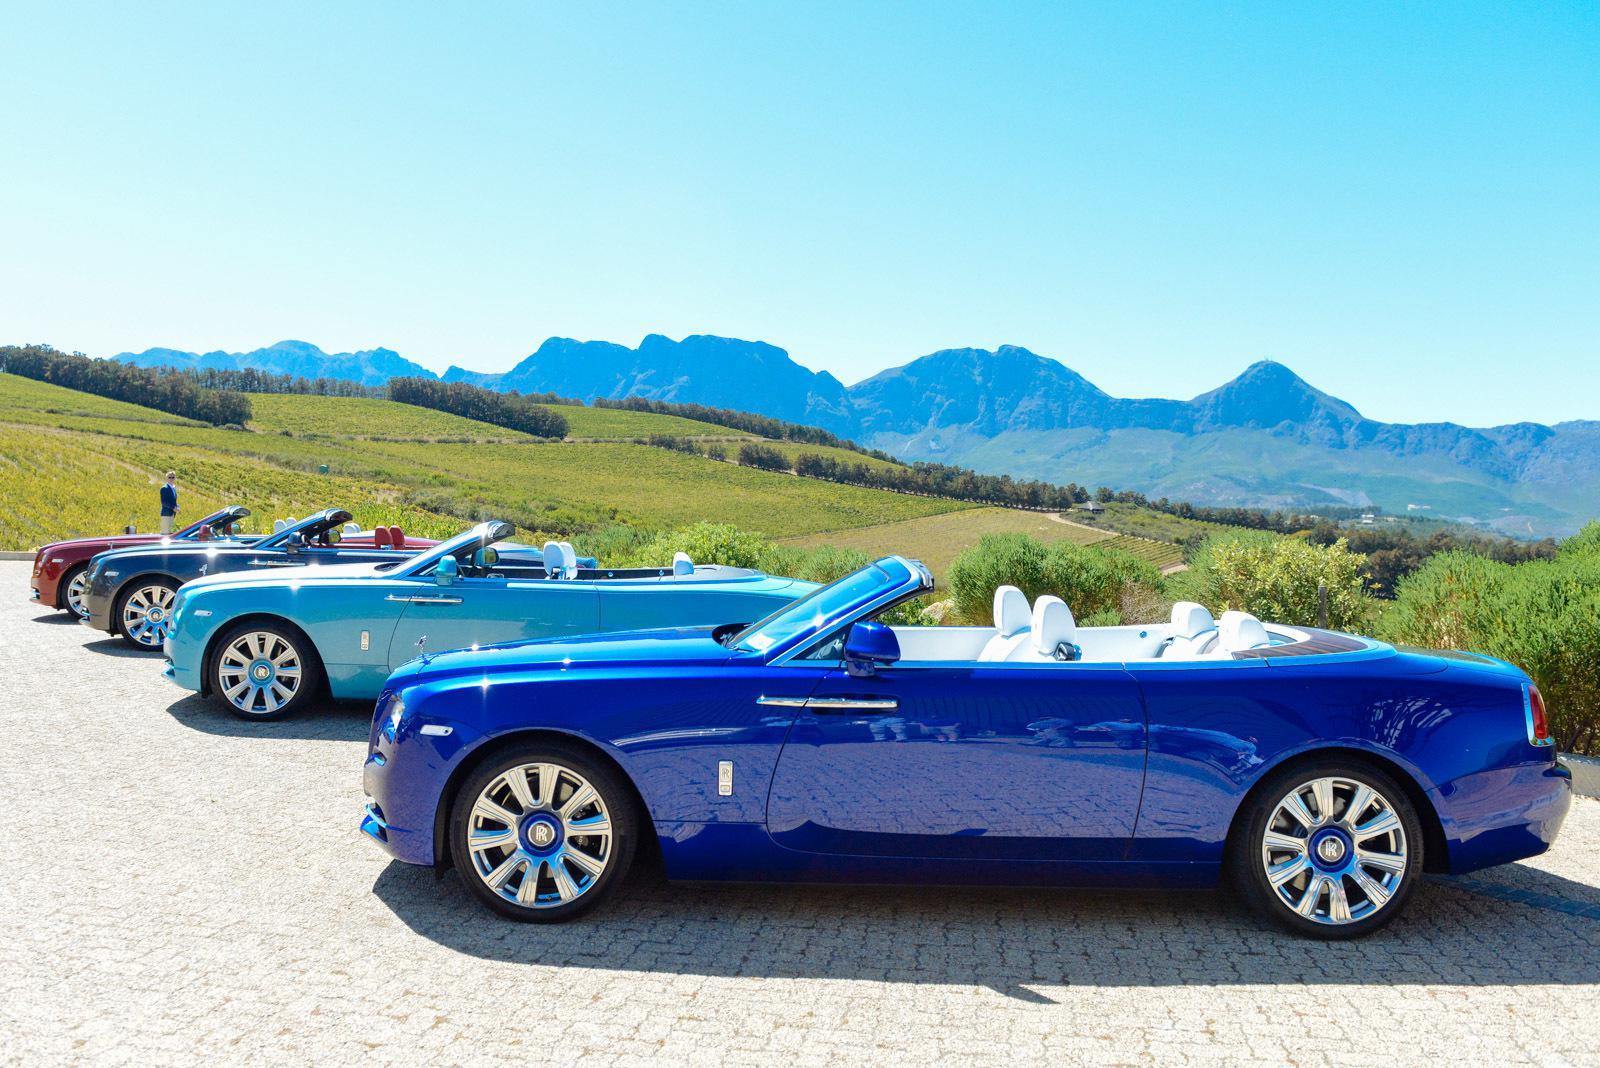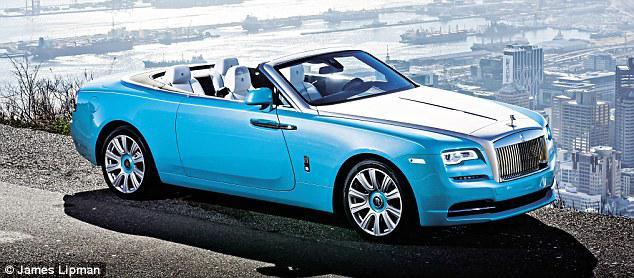The first image is the image on the left, the second image is the image on the right. Assess this claim about the two images: "In each image there is a blue convertible that is facing the left.". Correct or not? Answer yes or no. No. The first image is the image on the left, the second image is the image on the right. Evaluate the accuracy of this statement regarding the images: "There is a car with brown seats.". Is it true? Answer yes or no. No. 